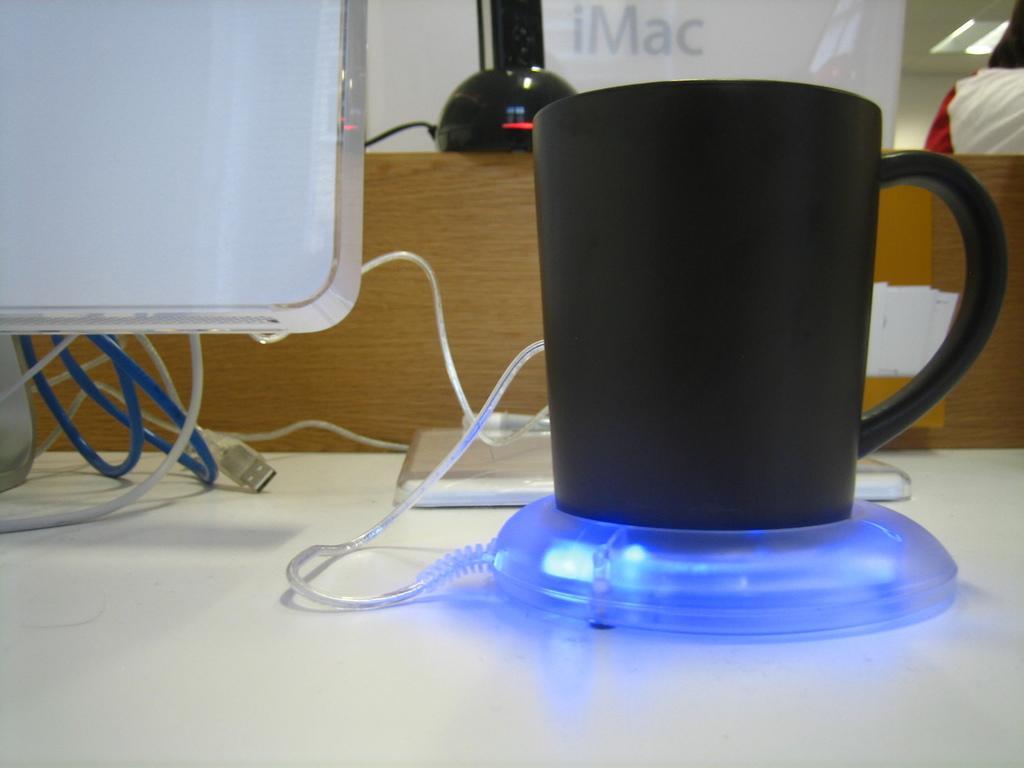Can you describe this image briefly? In this image we can see the wires, cup, cup warmer, white screen and one object on the white color surface. In the background, we can see wooden object, banner and one black color thing. We can see a person in the top right of the image. 